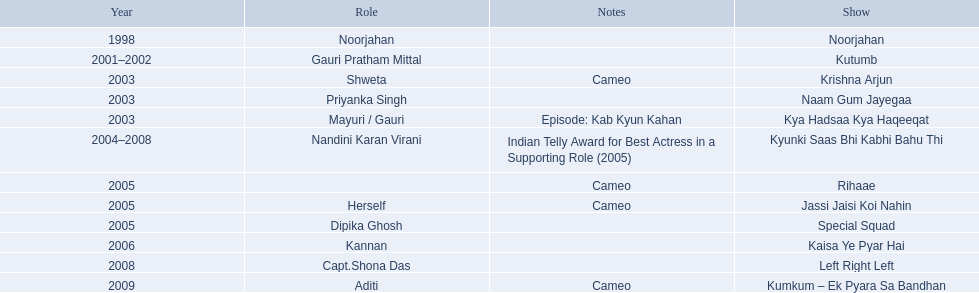What role  was played for the latest show Cameo. Who played the last cameo before ? Jassi Jaisi Koi Nahin. 